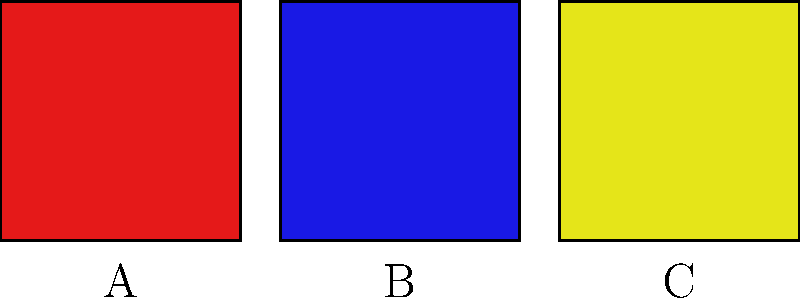Analyze the color swatches A, B, and C above, representative of an abstract expressionist composition. Which combination of these colors would create the most dynamic tension according to formalist color theory principles? 1. Identify the colors:
   A: Red
   B: Blue
   C: Yellow

2. Recall color theory principles:
   - Primary colors: Red, Blue, Yellow
   - Complementary colors create maximum contrast and tension

3. Analyze color relationships:
   - Red and Blue: Both primary, but not complementary
   - Red and Yellow: Both primary, but not complementary
   - Blue and Yellow: Complementary colors

4. Consider formalist principles:
   - Emphasis on visual elements over representational content
   - Seek maximum visual impact and tension

5. Evaluate combinations:
   - A+B (Red+Blue): Strong contrast, but not maximum tension
   - A+C (Red+Yellow): Vibrant, but not maximum tension
   - B+C (Blue+Yellow): Complementary, creating maximum tension

6. Conclude:
   The combination of B (Blue) and C (Yellow) would create the most dynamic tension according to formalist color theory principles, as they are complementary colors.
Answer: B and C (Blue and Yellow) 